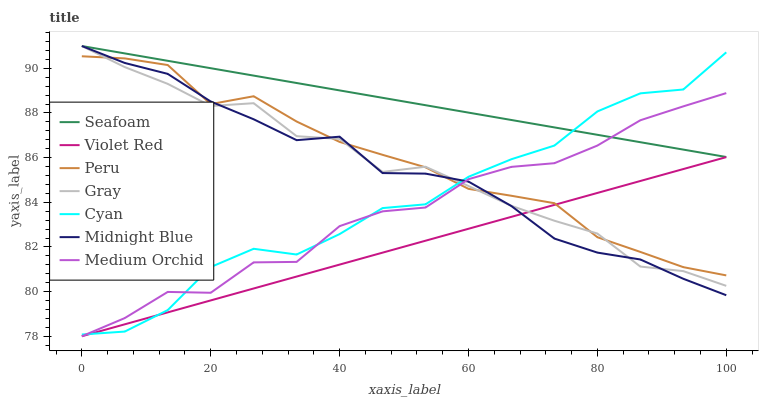Does Violet Red have the minimum area under the curve?
Answer yes or no. Yes. Does Seafoam have the maximum area under the curve?
Answer yes or no. Yes. Does Midnight Blue have the minimum area under the curve?
Answer yes or no. No. Does Midnight Blue have the maximum area under the curve?
Answer yes or no. No. Is Seafoam the smoothest?
Answer yes or no. Yes. Is Cyan the roughest?
Answer yes or no. Yes. Is Violet Red the smoothest?
Answer yes or no. No. Is Violet Red the roughest?
Answer yes or no. No. Does Violet Red have the lowest value?
Answer yes or no. Yes. Does Midnight Blue have the lowest value?
Answer yes or no. No. Does Seafoam have the highest value?
Answer yes or no. Yes. Does Violet Red have the highest value?
Answer yes or no. No. Is Peru less than Seafoam?
Answer yes or no. Yes. Is Seafoam greater than Violet Red?
Answer yes or no. Yes. Does Medium Orchid intersect Gray?
Answer yes or no. Yes. Is Medium Orchid less than Gray?
Answer yes or no. No. Is Medium Orchid greater than Gray?
Answer yes or no. No. Does Peru intersect Seafoam?
Answer yes or no. No. 